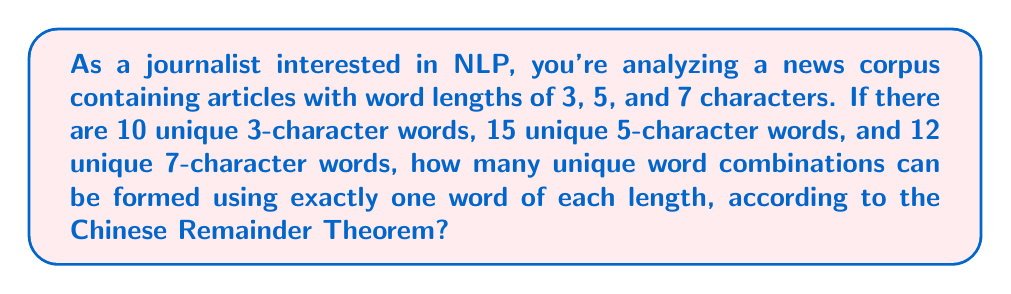Give your solution to this math problem. To solve this problem using the Chinese Remainder Theorem (CRT), we'll follow these steps:

1. Identify the moduli:
   $m_1 = 10$ (3-character words)
   $m_2 = 15$ (5-character words)
   $m_3 = 12$ (7-character words)

2. Calculate $M = m_1 \times m_2 \times m_3$:
   $M = 10 \times 15 \times 12 = 1800$

3. Calculate $M_i = M / m_i$ for each modulus:
   $M_1 = 1800 / 10 = 180$
   $M_2 = 1800 / 15 = 120$
   $M_3 = 1800 / 12 = 150$

4. Find the modular multiplicative inverses $y_i$ of $M_i$ modulo $m_i$:
   $180y_1 \equiv 1 \pmod{10} \Rightarrow y_1 = 6$
   $120y_2 \equiv 1 \pmod{15} \Rightarrow y_2 = 8$
   $150y_3 \equiv 1 \pmod{12} \Rightarrow y_3 = 6$

5. The CRT states that there exists a unique solution modulo $M$ for the system of congruences:
   $x \equiv 1 \pmod{10}$
   $x \equiv 1 \pmod{15}$
   $x \equiv 1 \pmod{12}$

6. The solution is given by:
   $x = (1 \times 180 \times 6 + 1 \times 120 \times 8 + 1 \times 150 \times 6) \pmod{1800}$
   $x = (1080 + 960 + 900) \pmod{1800}$
   $x = 2940 \pmod{1800}$
   $x = 1140$

7. Since $x = 1140$ is the smallest positive integer satisfying all congruences, this represents the number of unique word combinations.
Answer: 1140 unique word combinations 